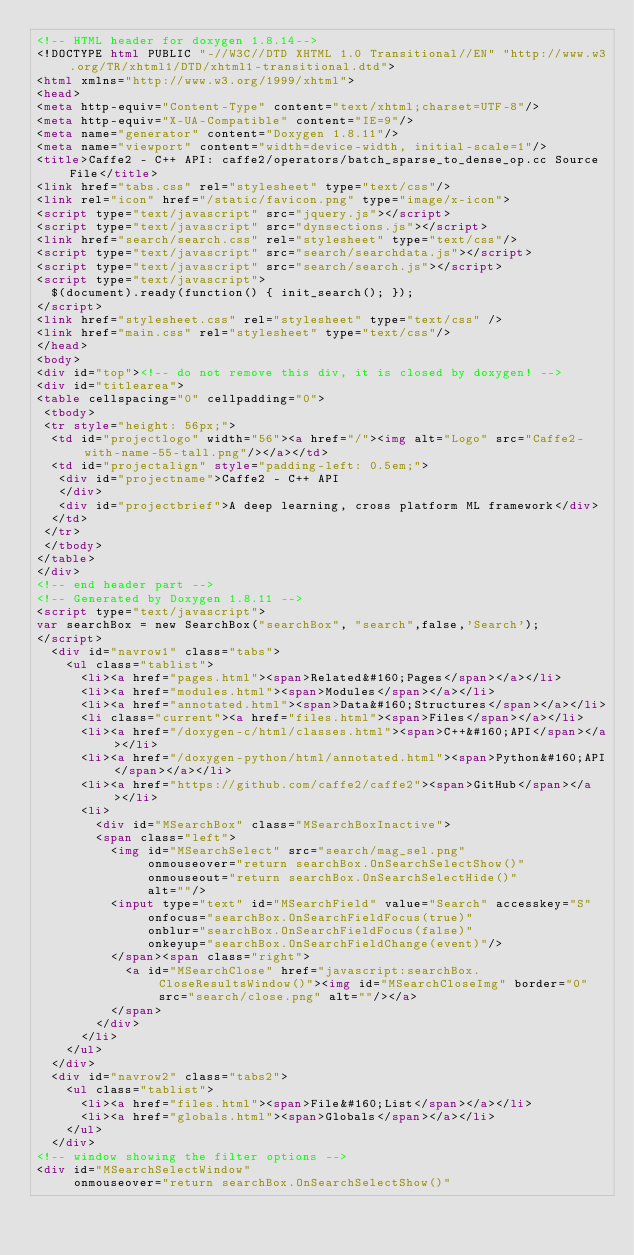Convert code to text. <code><loc_0><loc_0><loc_500><loc_500><_HTML_><!-- HTML header for doxygen 1.8.14-->
<!DOCTYPE html PUBLIC "-//W3C//DTD XHTML 1.0 Transitional//EN" "http://www.w3.org/TR/xhtml1/DTD/xhtml1-transitional.dtd">
<html xmlns="http://www.w3.org/1999/xhtml">
<head>
<meta http-equiv="Content-Type" content="text/xhtml;charset=UTF-8"/>
<meta http-equiv="X-UA-Compatible" content="IE=9"/>
<meta name="generator" content="Doxygen 1.8.11"/>
<meta name="viewport" content="width=device-width, initial-scale=1"/>
<title>Caffe2 - C++ API: caffe2/operators/batch_sparse_to_dense_op.cc Source File</title>
<link href="tabs.css" rel="stylesheet" type="text/css"/>
<link rel="icon" href="/static/favicon.png" type="image/x-icon">
<script type="text/javascript" src="jquery.js"></script>
<script type="text/javascript" src="dynsections.js"></script>
<link href="search/search.css" rel="stylesheet" type="text/css"/>
<script type="text/javascript" src="search/searchdata.js"></script>
<script type="text/javascript" src="search/search.js"></script>
<script type="text/javascript">
  $(document).ready(function() { init_search(); });
</script>
<link href="stylesheet.css" rel="stylesheet" type="text/css" />
<link href="main.css" rel="stylesheet" type="text/css"/>
</head>
<body>
<div id="top"><!-- do not remove this div, it is closed by doxygen! -->
<div id="titlearea">
<table cellspacing="0" cellpadding="0">
 <tbody>
 <tr style="height: 56px;">
  <td id="projectlogo" width="56"><a href="/"><img alt="Logo" src="Caffe2-with-name-55-tall.png"/></a></td>
  <td id="projectalign" style="padding-left: 0.5em;">
   <div id="projectname">Caffe2 - C++ API
   </div>
   <div id="projectbrief">A deep learning, cross platform ML framework</div>
  </td>
 </tr>
 </tbody>
</table>
</div>
<!-- end header part -->
<!-- Generated by Doxygen 1.8.11 -->
<script type="text/javascript">
var searchBox = new SearchBox("searchBox", "search",false,'Search');
</script>
  <div id="navrow1" class="tabs">
    <ul class="tablist">
      <li><a href="pages.html"><span>Related&#160;Pages</span></a></li>
      <li><a href="modules.html"><span>Modules</span></a></li>
      <li><a href="annotated.html"><span>Data&#160;Structures</span></a></li>
      <li class="current"><a href="files.html"><span>Files</span></a></li>
      <li><a href="/doxygen-c/html/classes.html"><span>C++&#160;API</span></a></li>
      <li><a href="/doxygen-python/html/annotated.html"><span>Python&#160;API</span></a></li>
      <li><a href="https://github.com/caffe2/caffe2"><span>GitHub</span></a></li>
      <li>
        <div id="MSearchBox" class="MSearchBoxInactive">
        <span class="left">
          <img id="MSearchSelect" src="search/mag_sel.png"
               onmouseover="return searchBox.OnSearchSelectShow()"
               onmouseout="return searchBox.OnSearchSelectHide()"
               alt=""/>
          <input type="text" id="MSearchField" value="Search" accesskey="S"
               onfocus="searchBox.OnSearchFieldFocus(true)" 
               onblur="searchBox.OnSearchFieldFocus(false)" 
               onkeyup="searchBox.OnSearchFieldChange(event)"/>
          </span><span class="right">
            <a id="MSearchClose" href="javascript:searchBox.CloseResultsWindow()"><img id="MSearchCloseImg" border="0" src="search/close.png" alt=""/></a>
          </span>
        </div>
      </li>
    </ul>
  </div>
  <div id="navrow2" class="tabs2">
    <ul class="tablist">
      <li><a href="files.html"><span>File&#160;List</span></a></li>
      <li><a href="globals.html"><span>Globals</span></a></li>
    </ul>
  </div>
<!-- window showing the filter options -->
<div id="MSearchSelectWindow"
     onmouseover="return searchBox.OnSearchSelectShow()"</code> 